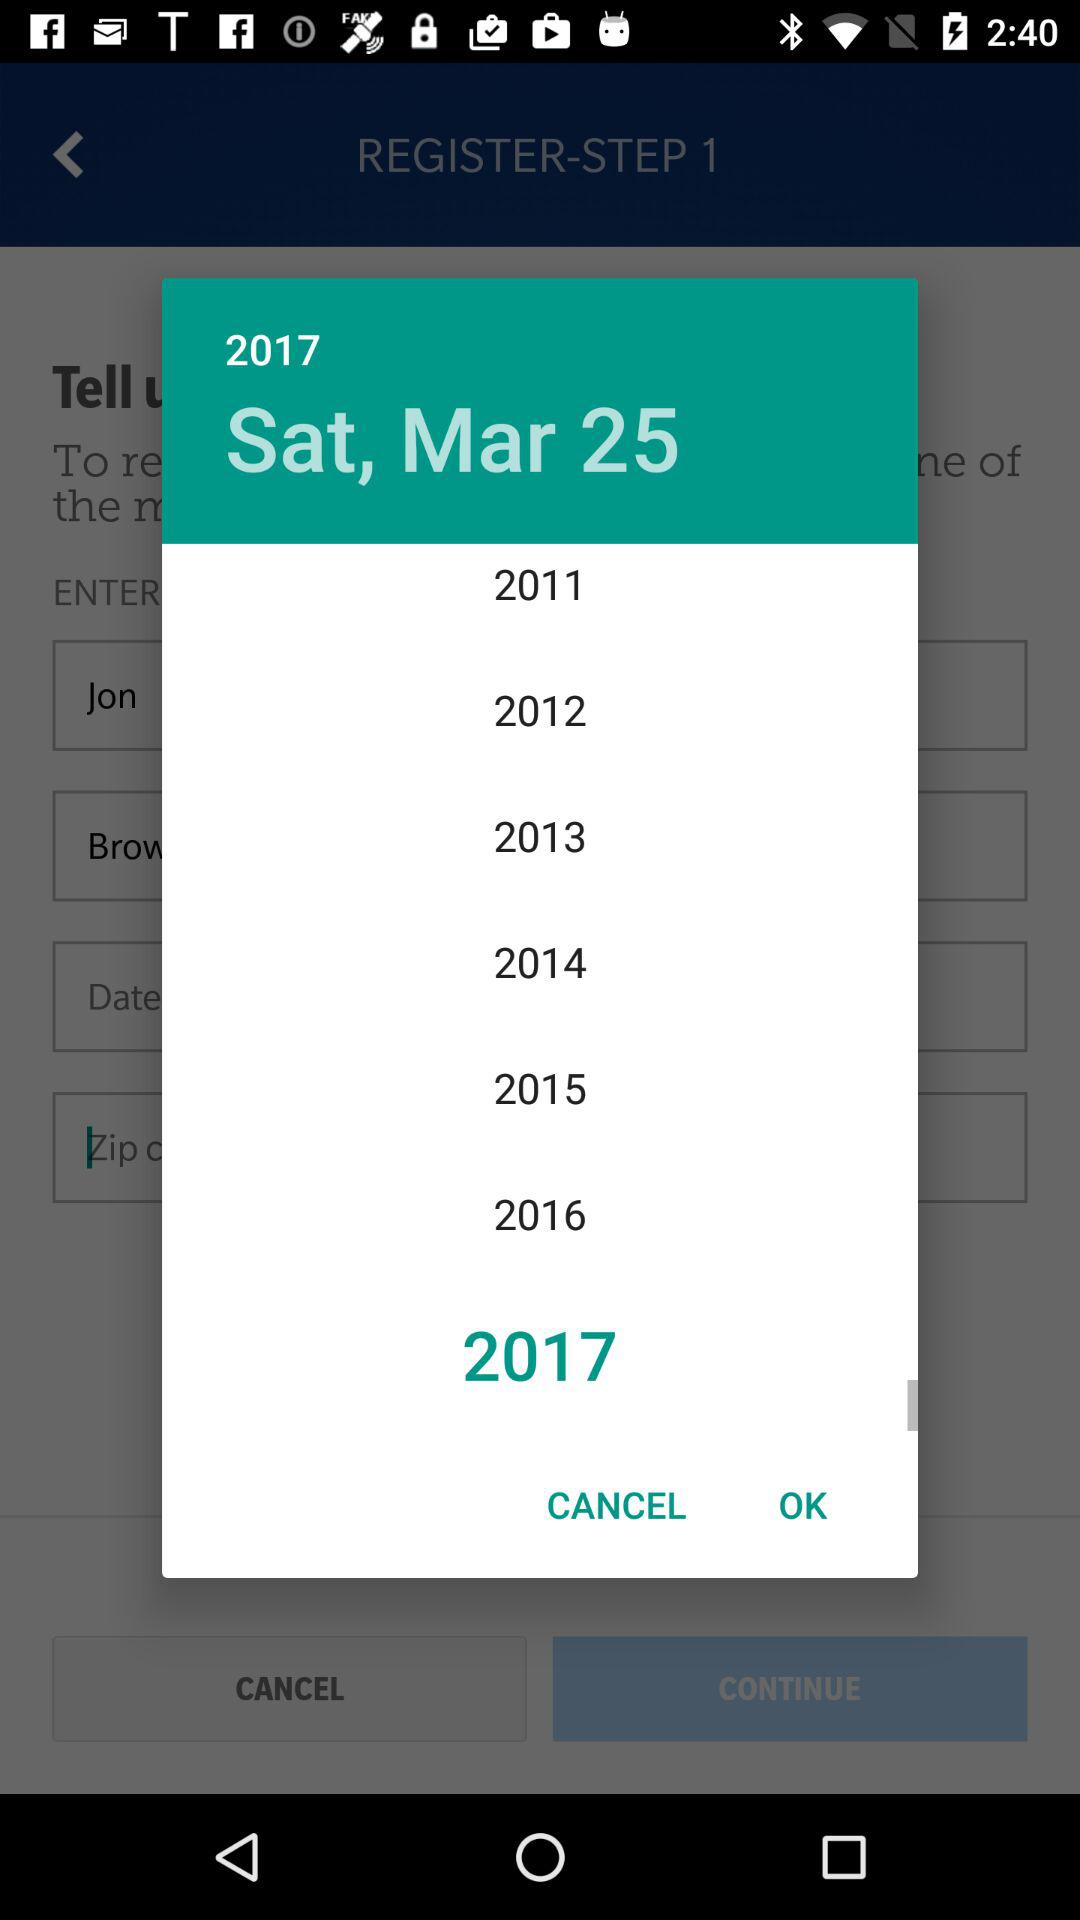What is the date? The date is Saturday, March 25, 2017. 